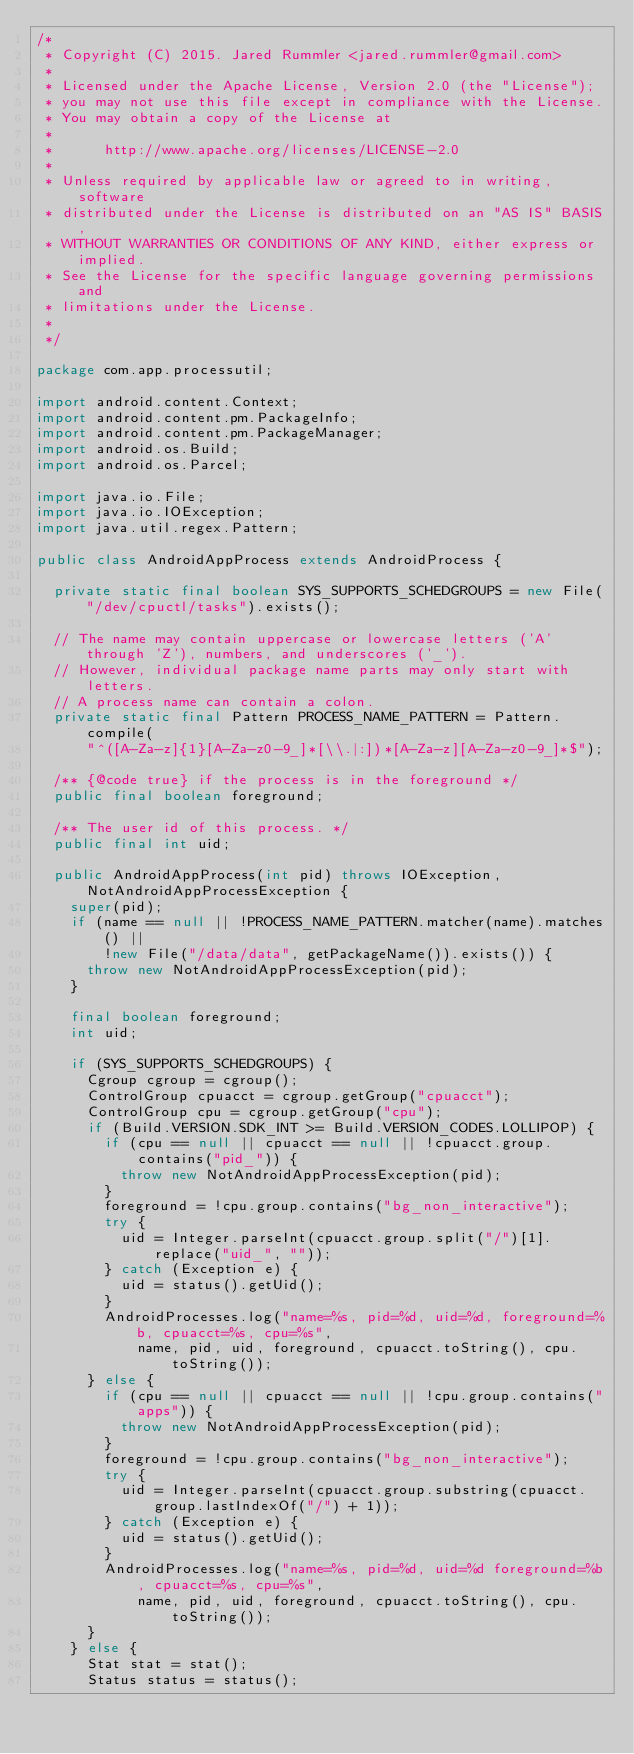Convert code to text. <code><loc_0><loc_0><loc_500><loc_500><_Java_>/*
 * Copyright (C) 2015. Jared Rummler <jared.rummler@gmail.com>
 *
 * Licensed under the Apache License, Version 2.0 (the "License");
 * you may not use this file except in compliance with the License.
 * You may obtain a copy of the License at
 *
 *      http://www.apache.org/licenses/LICENSE-2.0
 *
 * Unless required by applicable law or agreed to in writing, software
 * distributed under the License is distributed on an "AS IS" BASIS,
 * WITHOUT WARRANTIES OR CONDITIONS OF ANY KIND, either express or implied.
 * See the License for the specific language governing permissions and
 * limitations under the License.
 *
 */

package com.app.processutil;

import android.content.Context;
import android.content.pm.PackageInfo;
import android.content.pm.PackageManager;
import android.os.Build;
import android.os.Parcel;

import java.io.File;
import java.io.IOException;
import java.util.regex.Pattern;

public class AndroidAppProcess extends AndroidProcess {

  private static final boolean SYS_SUPPORTS_SCHEDGROUPS = new File("/dev/cpuctl/tasks").exists();

  // The name may contain uppercase or lowercase letters ('A' through 'Z'), numbers, and underscores ('_').
  // However, individual package name parts may only start with letters.
  // A process name can contain a colon.
  private static final Pattern PROCESS_NAME_PATTERN = Pattern.compile(
      "^([A-Za-z]{1}[A-Za-z0-9_]*[\\.|:])*[A-Za-z][A-Za-z0-9_]*$");

  /** {@code true} if the process is in the foreground */
  public final boolean foreground;

  /** The user id of this process. */
  public final int uid;

  public AndroidAppProcess(int pid) throws IOException, NotAndroidAppProcessException {
    super(pid);
    if (name == null || !PROCESS_NAME_PATTERN.matcher(name).matches() ||
        !new File("/data/data", getPackageName()).exists()) {
      throw new NotAndroidAppProcessException(pid);
    }

    final boolean foreground;
    int uid;

    if (SYS_SUPPORTS_SCHEDGROUPS) {
      Cgroup cgroup = cgroup();
      ControlGroup cpuacct = cgroup.getGroup("cpuacct");
      ControlGroup cpu = cgroup.getGroup("cpu");
      if (Build.VERSION.SDK_INT >= Build.VERSION_CODES.LOLLIPOP) {
        if (cpu == null || cpuacct == null || !cpuacct.group.contains("pid_")) {
          throw new NotAndroidAppProcessException(pid);
        }
        foreground = !cpu.group.contains("bg_non_interactive");
        try {
          uid = Integer.parseInt(cpuacct.group.split("/")[1].replace("uid_", ""));
        } catch (Exception e) {
          uid = status().getUid();
        }
        AndroidProcesses.log("name=%s, pid=%d, uid=%d, foreground=%b, cpuacct=%s, cpu=%s",
            name, pid, uid, foreground, cpuacct.toString(), cpu.toString());
      } else {
        if (cpu == null || cpuacct == null || !cpu.group.contains("apps")) {
          throw new NotAndroidAppProcessException(pid);
        }
        foreground = !cpu.group.contains("bg_non_interactive");
        try {
          uid = Integer.parseInt(cpuacct.group.substring(cpuacct.group.lastIndexOf("/") + 1));
        } catch (Exception e) {
          uid = status().getUid();
        }
        AndroidProcesses.log("name=%s, pid=%d, uid=%d foreground=%b, cpuacct=%s, cpu=%s",
            name, pid, uid, foreground, cpuacct.toString(), cpu.toString());
      }
    } else {
      Stat stat = stat();
      Status status = status();</code> 